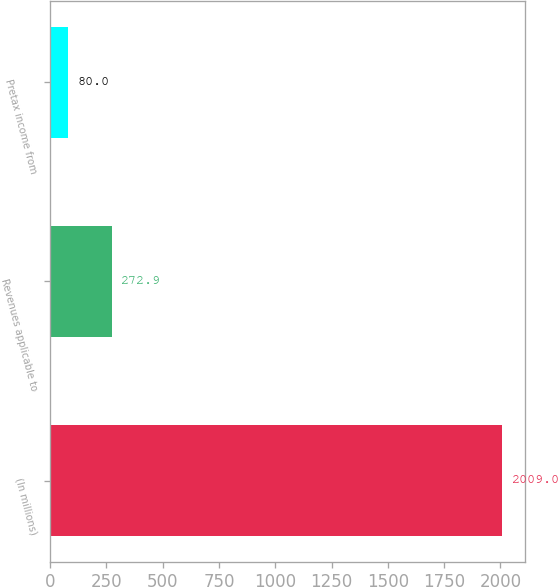<chart> <loc_0><loc_0><loc_500><loc_500><bar_chart><fcel>(In millions)<fcel>Revenues applicable to<fcel>Pretax income from<nl><fcel>2009<fcel>272.9<fcel>80<nl></chart> 